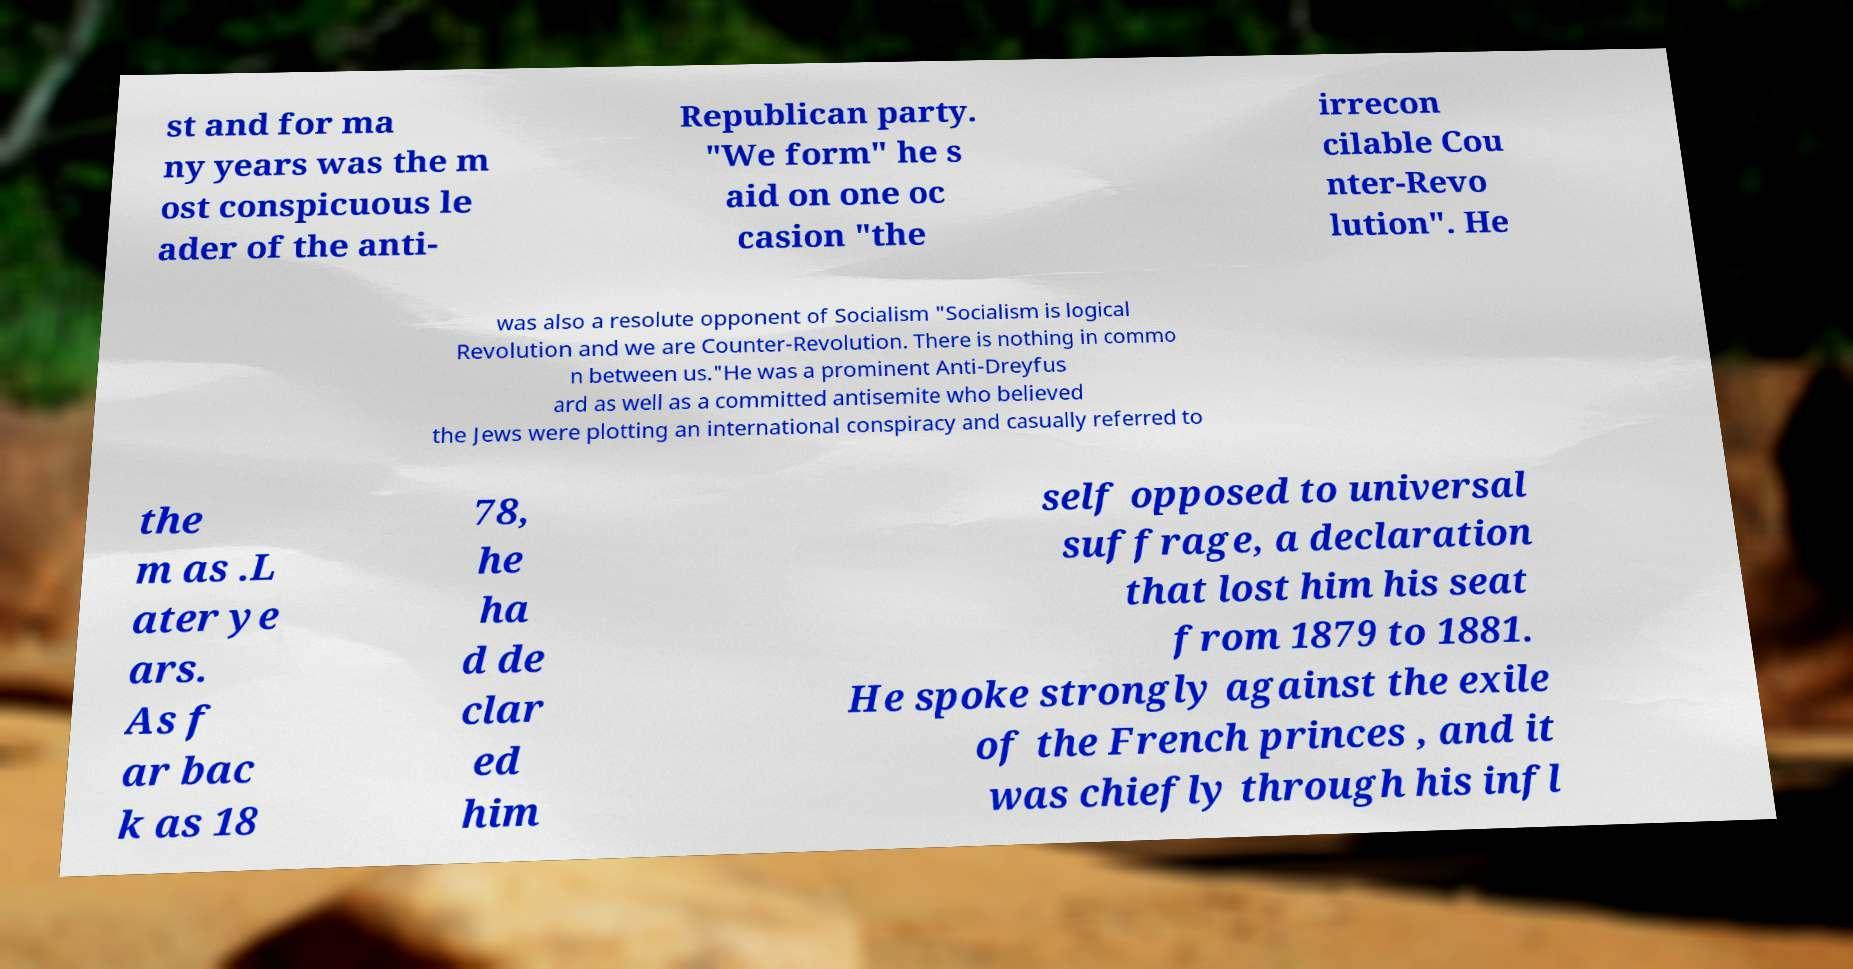Can you read and provide the text displayed in the image?This photo seems to have some interesting text. Can you extract and type it out for me? st and for ma ny years was the m ost conspicuous le ader of the anti- Republican party. "We form" he s aid on one oc casion "the irrecon cilable Cou nter-Revo lution". He was also a resolute opponent of Socialism "Socialism is logical Revolution and we are Counter-Revolution. There is nothing in commo n between us."He was a prominent Anti-Dreyfus ard as well as a committed antisemite who believed the Jews were plotting an international conspiracy and casually referred to the m as .L ater ye ars. As f ar bac k as 18 78, he ha d de clar ed him self opposed to universal suffrage, a declaration that lost him his seat from 1879 to 1881. He spoke strongly against the exile of the French princes , and it was chiefly through his infl 